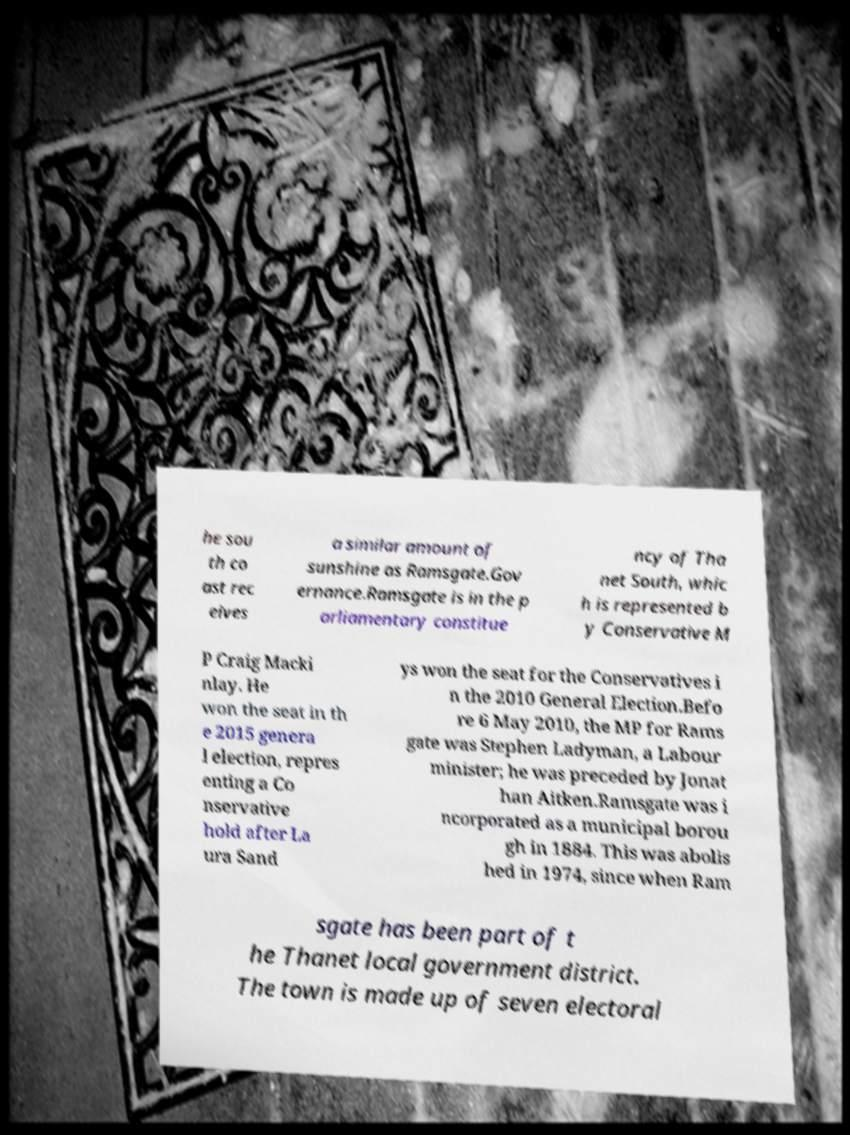Can you read and provide the text displayed in the image?This photo seems to have some interesting text. Can you extract and type it out for me? he sou th co ast rec eives a similar amount of sunshine as Ramsgate.Gov ernance.Ramsgate is in the p arliamentary constitue ncy of Tha net South, whic h is represented b y Conservative M P Craig Macki nlay. He won the seat in th e 2015 genera l election, repres enting a Co nservative hold after La ura Sand ys won the seat for the Conservatives i n the 2010 General Election.Befo re 6 May 2010, the MP for Rams gate was Stephen Ladyman, a Labour minister; he was preceded by Jonat han Aitken.Ramsgate was i ncorporated as a municipal borou gh in 1884. This was abolis hed in 1974, since when Ram sgate has been part of t he Thanet local government district. The town is made up of seven electoral 